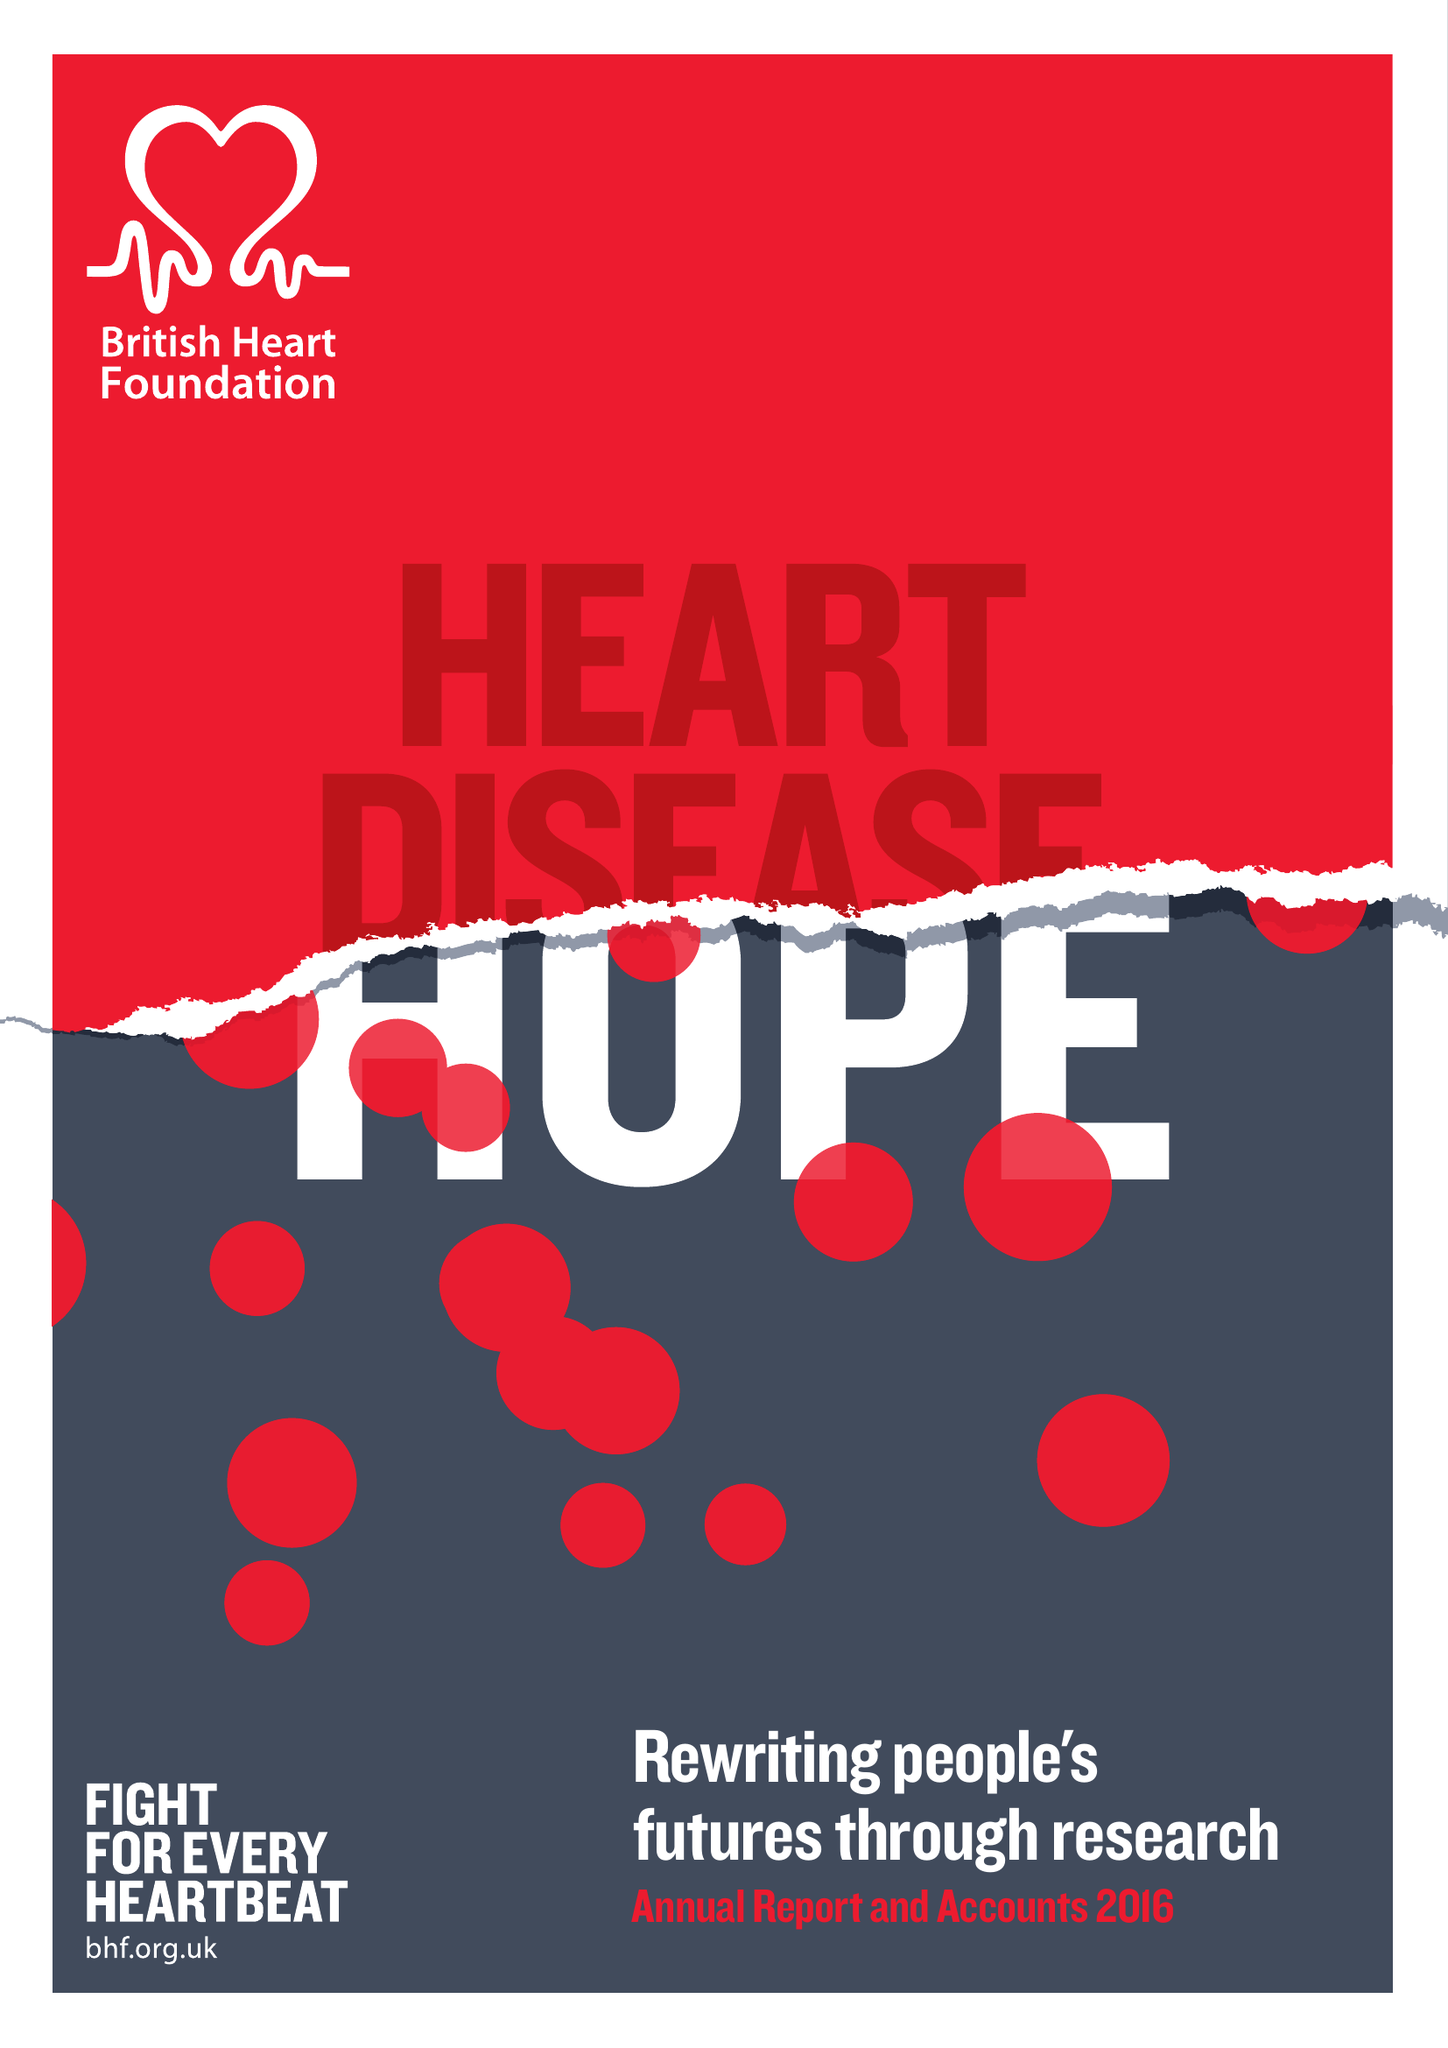What is the value for the report_date?
Answer the question using a single word or phrase. 2016-03-31 